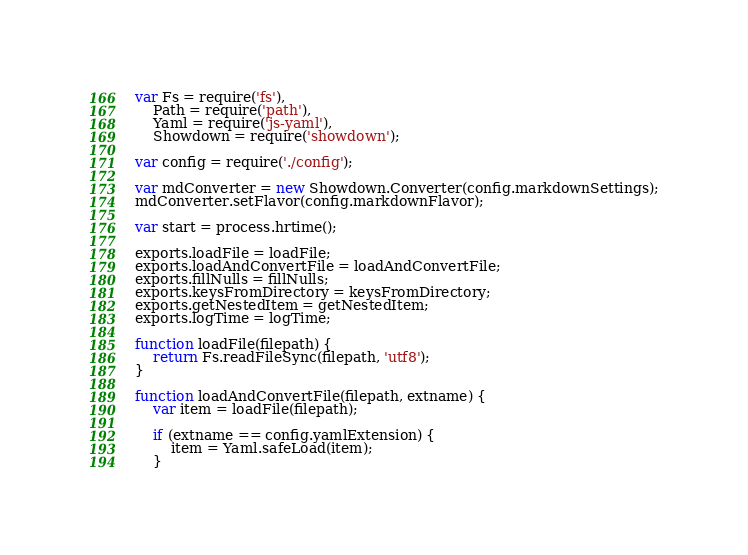Convert code to text. <code><loc_0><loc_0><loc_500><loc_500><_JavaScript_>var Fs = require('fs'),
	Path = require('path'),
	Yaml = require('js-yaml'),
	Showdown = require('showdown');

var config = require('./config');

var mdConverter = new Showdown.Converter(config.markdownSettings);
mdConverter.setFlavor(config.markdownFlavor);

var start = process.hrtime();

exports.loadFile = loadFile;
exports.loadAndConvertFile = loadAndConvertFile;
exports.fillNulls = fillNulls;
exports.keysFromDirectory = keysFromDirectory;
exports.getNestedItem = getNestedItem;
exports.logTime = logTime;

function loadFile(filepath) {
	return Fs.readFileSync(filepath, 'utf8');
}

function loadAndConvertFile(filepath, extname) {
	var item = loadFile(filepath);

	if (extname == config.yamlExtension) {
		item = Yaml.safeLoad(item);
	}</code> 